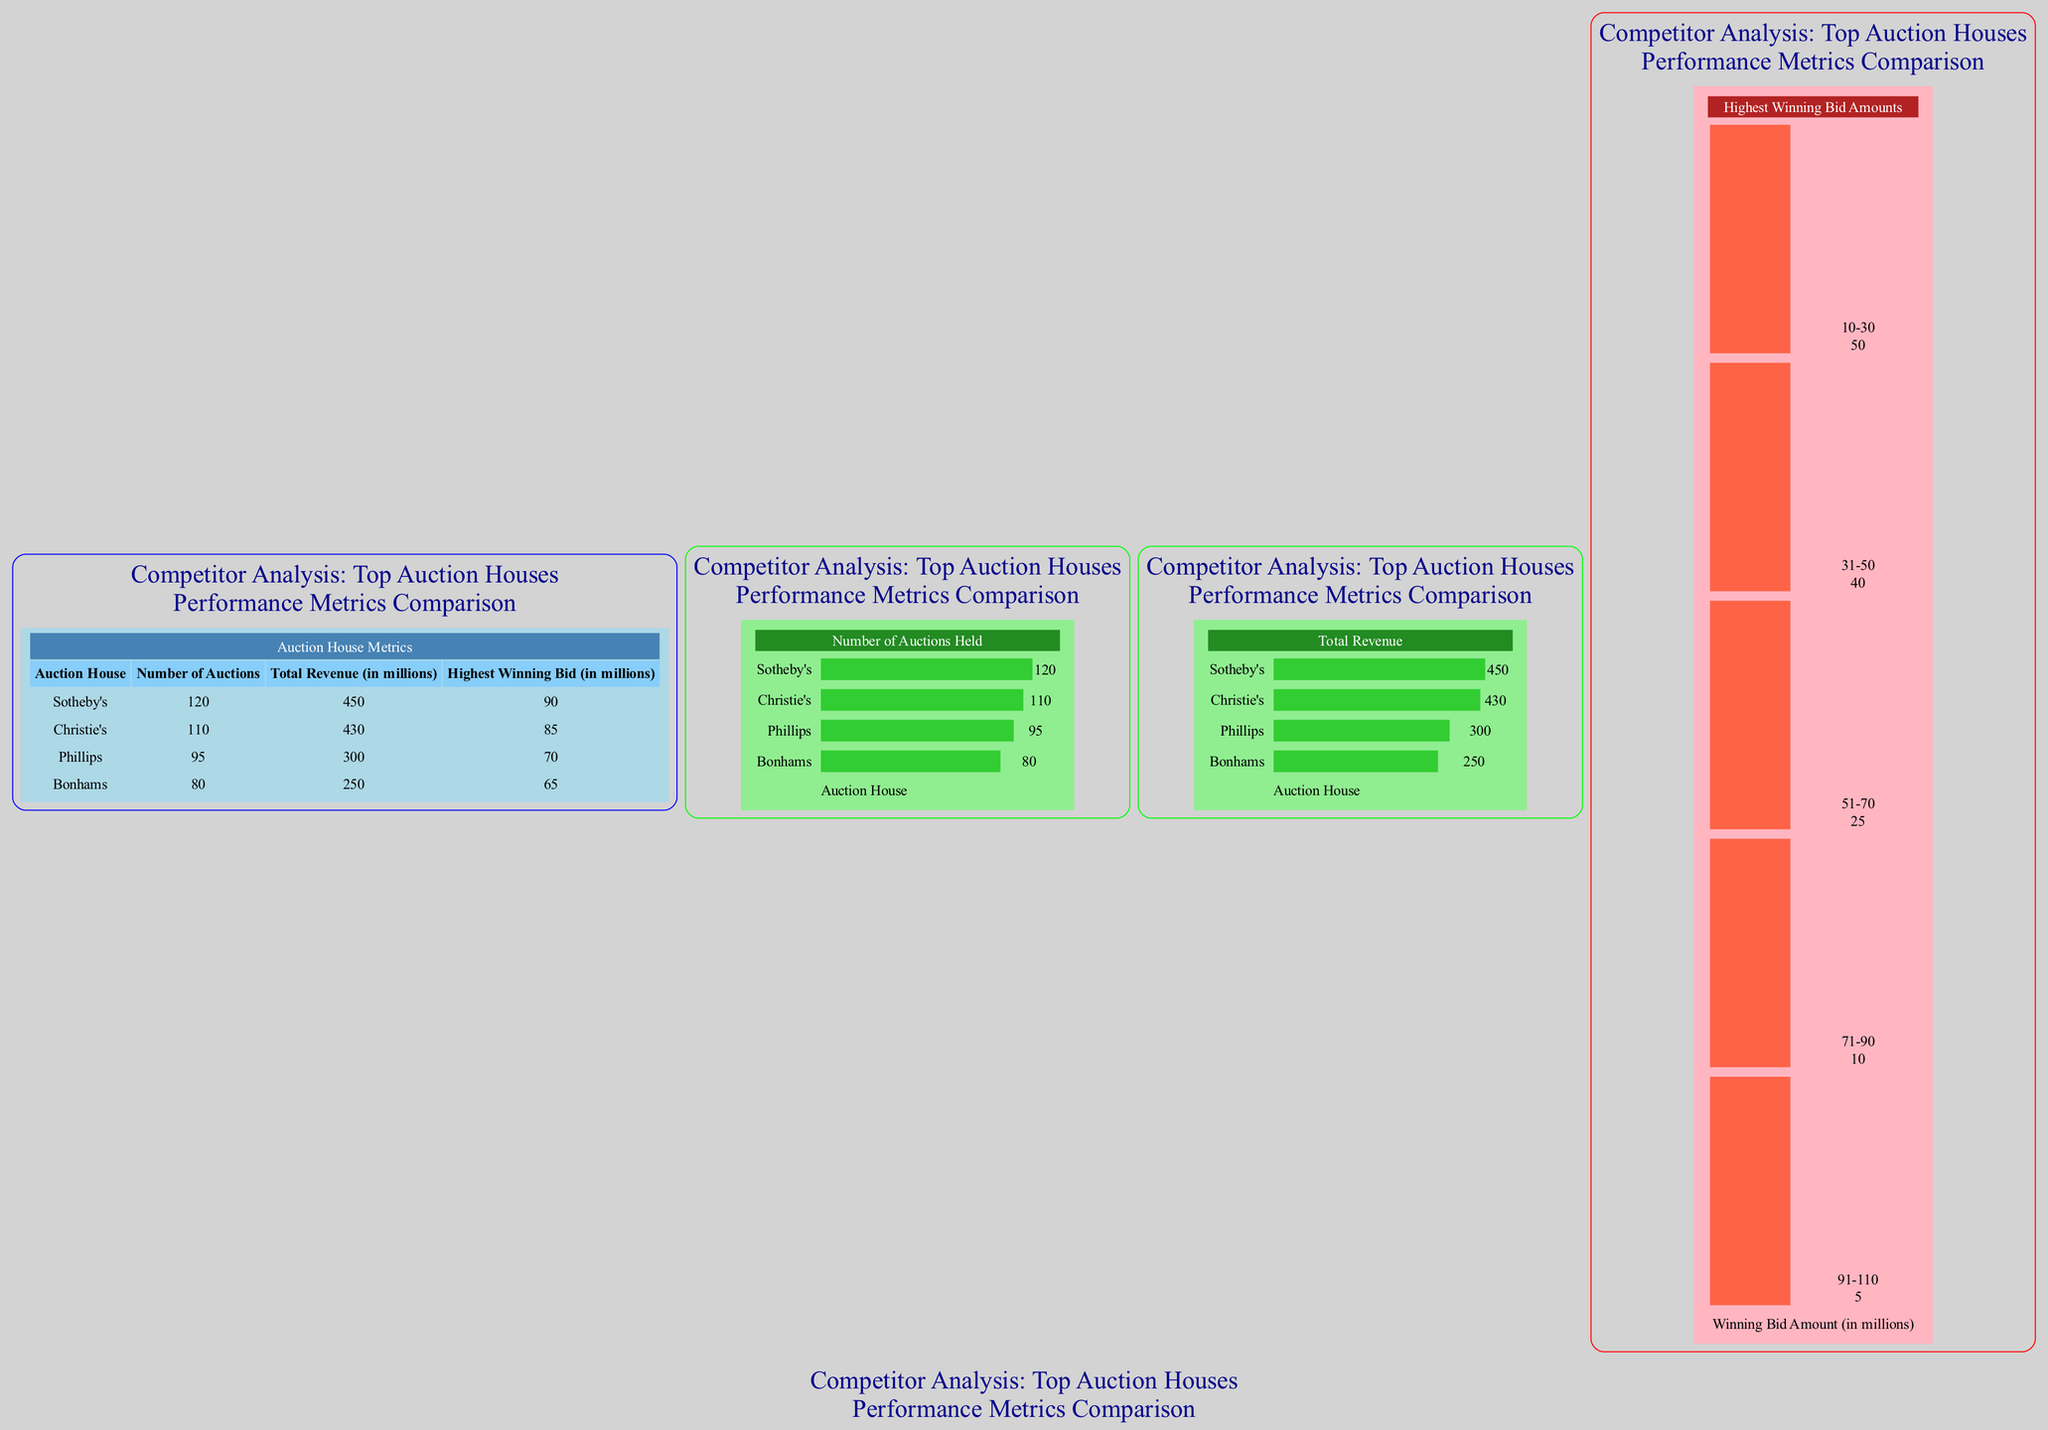What is the total revenue for Sotheby's? In the table under the "Total Revenue (in millions)" column, the row corresponding to Sotheby's lists the value 450.
Answer: 450 Which auction house held the highest number of auctions? Looking at the "Number of Auctions" in the first element (table), Sotheby's has the highest number, which is 120.
Answer: Sotheby's What is the highest winning bid for Phillips? In the table, under the "Highest Winning Bid (in millions)" column, Phillips has a value of 70 listed.
Answer: 70 How many auctions were held by Bonhams? From the table, we see Bonhams has a value of 80 in the "Number of Auctions" column.
Answer: 80 What is the total revenue of Christie's compared to Bonhams? Christie's has a total revenue of 430 million while Bonhams has 250 million. Therefore, Christie's total revenue is higher by 180 million (430 - 250).
Answer: 180 million How many auction houses have a highest winning bid amount exceeding 70 million? By analyzing the "Highest Winning Bid" figures, Sotheby's (90), Christie's (85), and Phillips (70) have bids of 70 million or higher. That totals to three auction houses.
Answer: 3 What is the frequency of winning bids in the range of 10-30 million? The "Highest Winning Bid Amounts" histogram shows that the frequency for the 10-30 range is 50.
Answer: 50 Which auction house had total revenue close to 400 million? Christie's has a total revenue of 430 million, which is the closest value to 400 among the listed auction houses.
Answer: Christie's What percentage of total revenue does Phillips represent when compared to Sotheby's revenue? To find this, divide Phillips' revenue (300 million) by Sotheby's revenue (450 million) and multiply by 100, yielding approximately 66.67%.
Answer: 66.67% 